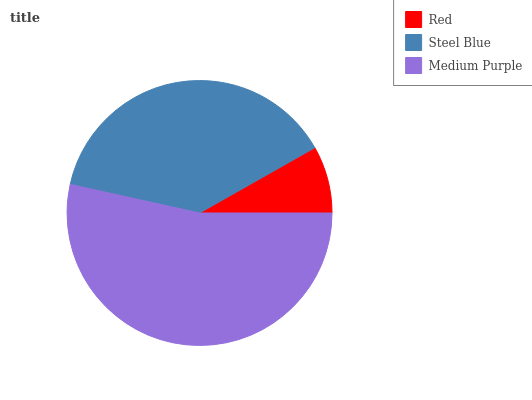Is Red the minimum?
Answer yes or no. Yes. Is Medium Purple the maximum?
Answer yes or no. Yes. Is Steel Blue the minimum?
Answer yes or no. No. Is Steel Blue the maximum?
Answer yes or no. No. Is Steel Blue greater than Red?
Answer yes or no. Yes. Is Red less than Steel Blue?
Answer yes or no. Yes. Is Red greater than Steel Blue?
Answer yes or no. No. Is Steel Blue less than Red?
Answer yes or no. No. Is Steel Blue the high median?
Answer yes or no. Yes. Is Steel Blue the low median?
Answer yes or no. Yes. Is Medium Purple the high median?
Answer yes or no. No. Is Medium Purple the low median?
Answer yes or no. No. 